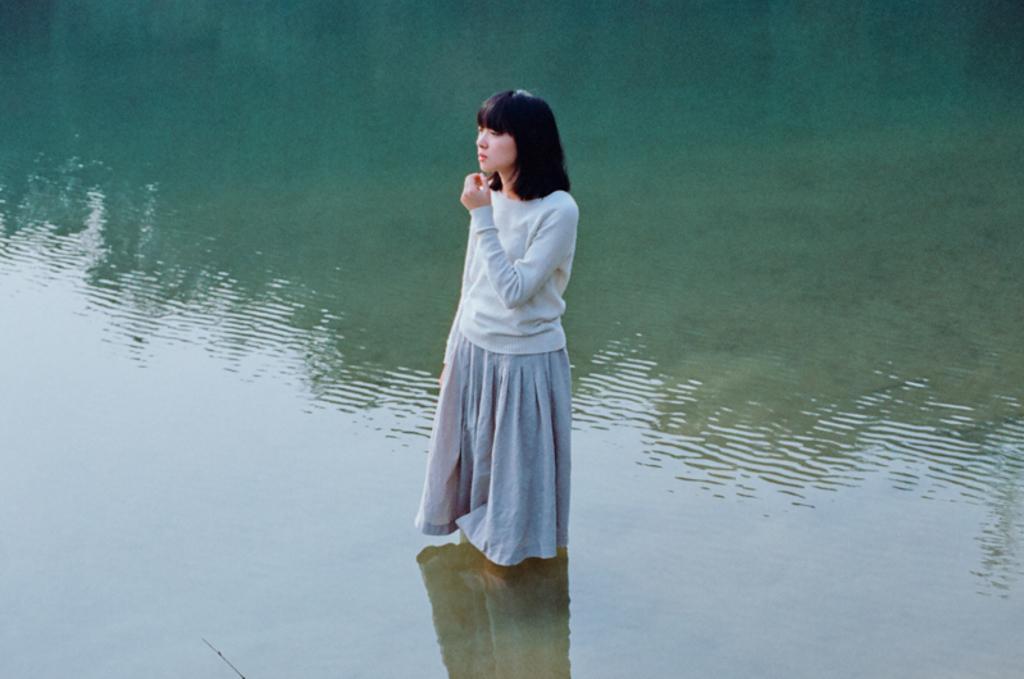In one or two sentences, can you explain what this image depicts? In this image we can see a person standing in the water. 